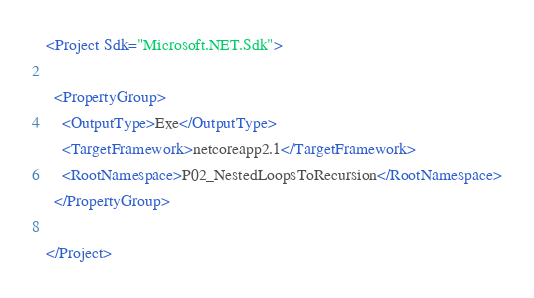<code> <loc_0><loc_0><loc_500><loc_500><_XML_><Project Sdk="Microsoft.NET.Sdk">

  <PropertyGroup>
    <OutputType>Exe</OutputType>
    <TargetFramework>netcoreapp2.1</TargetFramework>
    <RootNamespace>P02_NestedLoopsToRecursion</RootNamespace>
  </PropertyGroup>

</Project>
</code> 